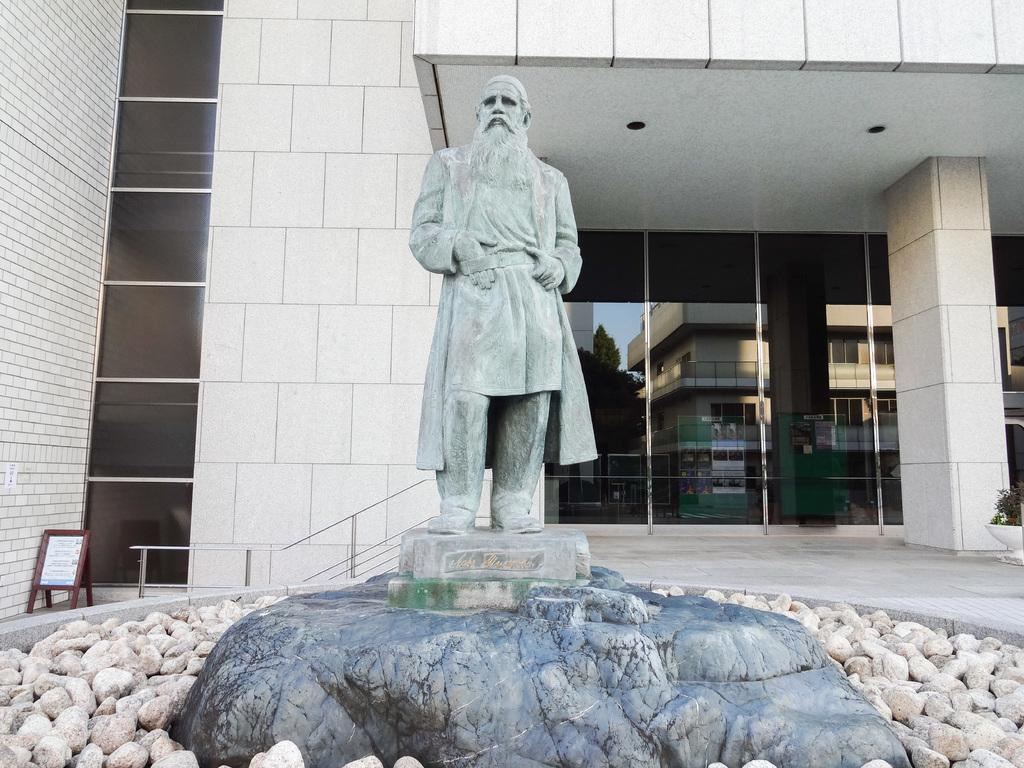What is the main subject of the image? There is a statue in the image. How is the statue positioned in the image? The statue is on a pedestal. What type of material can be seen in the image? There are stones in the image. What type of structure is visible in the image? There is a building in the image. What architectural feature can be seen in the image? There is a railing in the image. What might provide information about the statue or the location? There is an information board in the image. What type of plant is present in the image? There is a houseplant in the image. Can you tell me how many volcanoes are visible in the image? There are no volcanoes visible in the image. What type of sun is depicted on the statue in the image? The statue does not depict a sun; it is a statue of a different subject. 